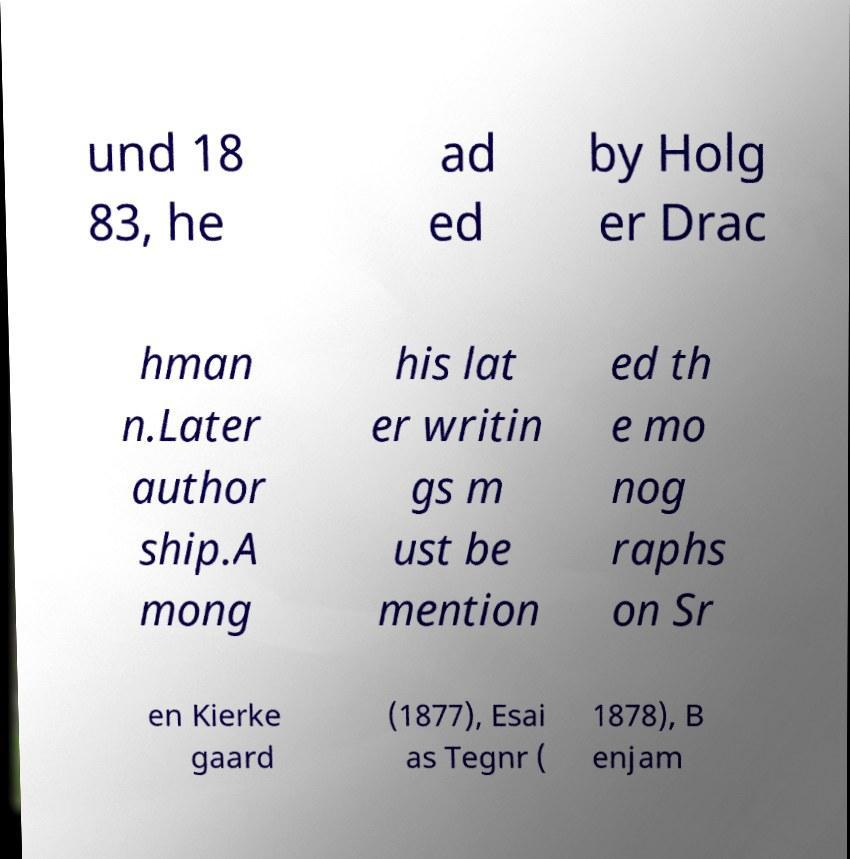For documentation purposes, I need the text within this image transcribed. Could you provide that? und 18 83, he ad ed by Holg er Drac hman n.Later author ship.A mong his lat er writin gs m ust be mention ed th e mo nog raphs on Sr en Kierke gaard (1877), Esai as Tegnr ( 1878), B enjam 